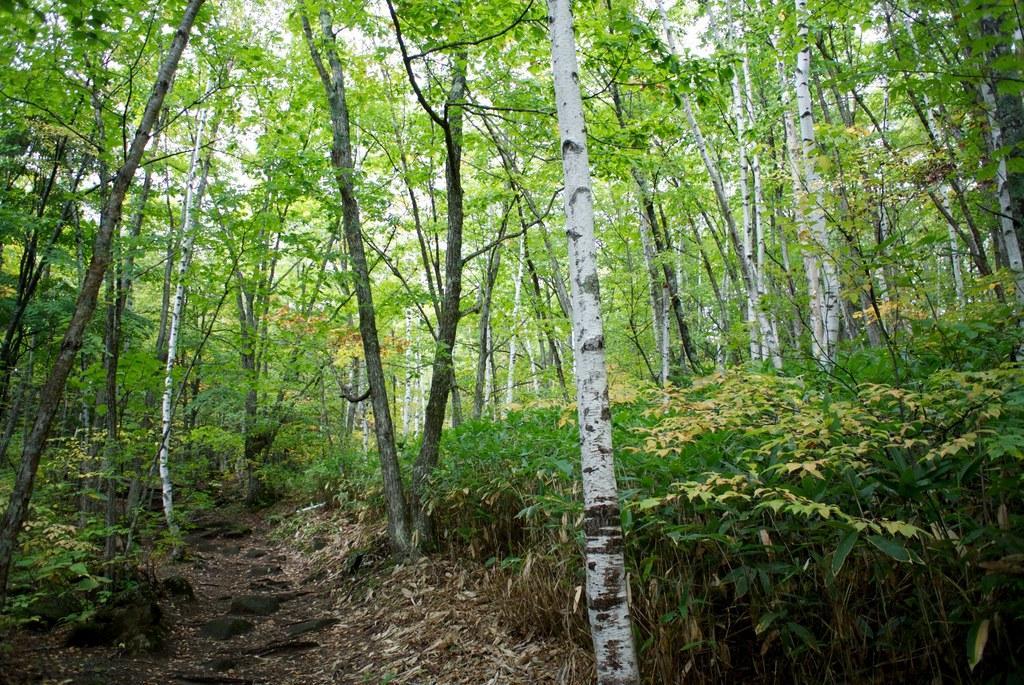Describe this image in one or two sentences. In this image we can see plants and trees. Through the trees we can see able to see the sky.  